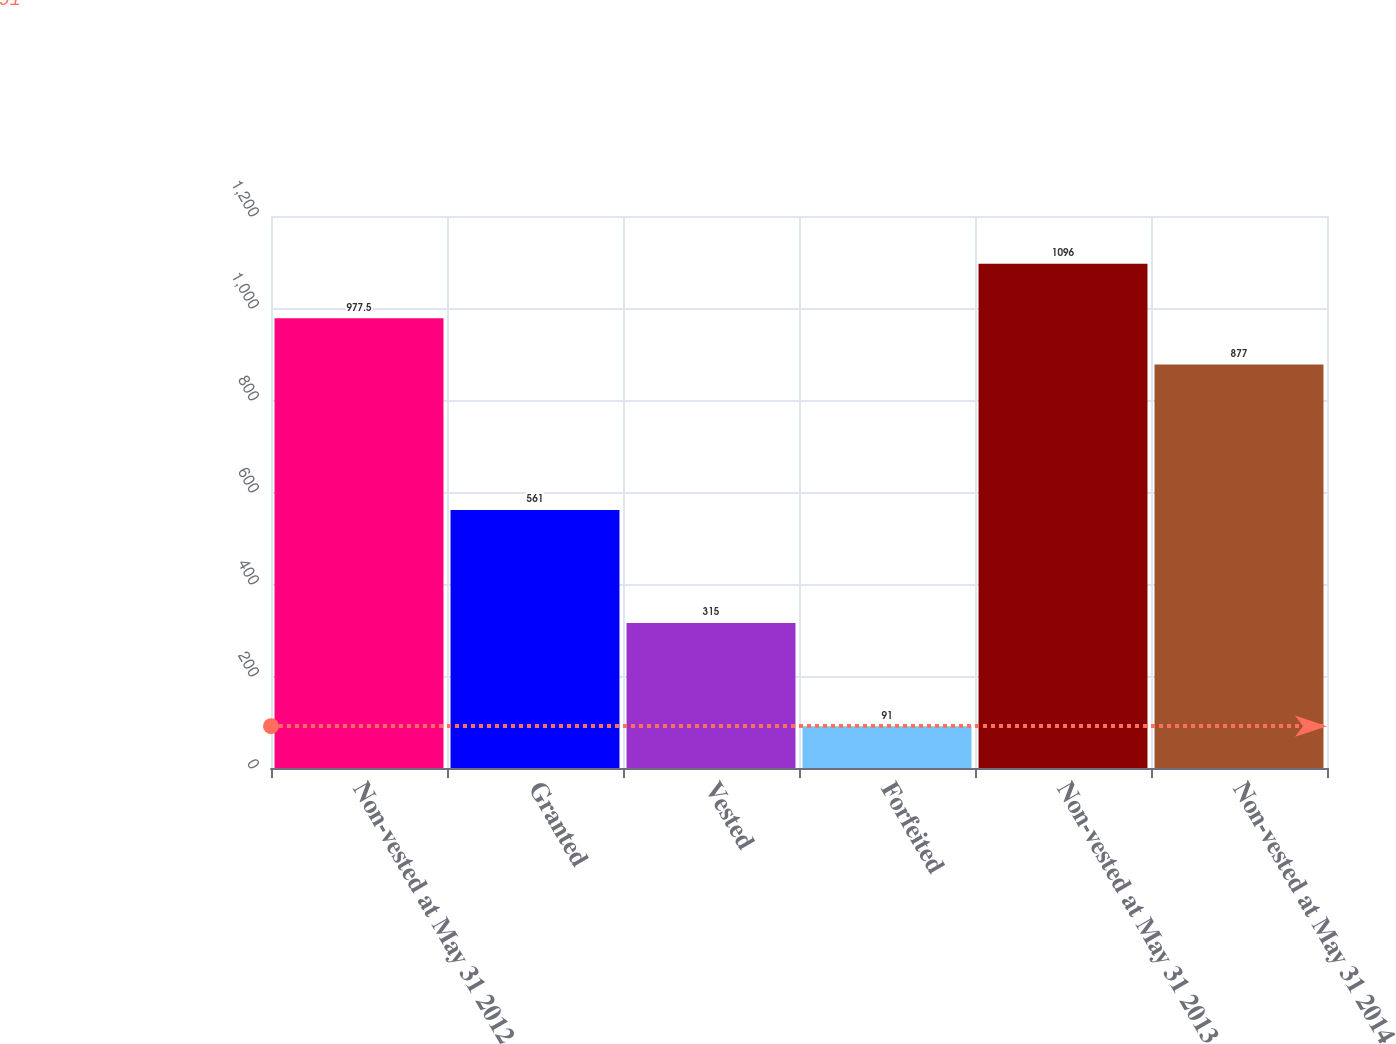<chart> <loc_0><loc_0><loc_500><loc_500><bar_chart><fcel>Non-vested at May 31 2012<fcel>Granted<fcel>Vested<fcel>Forfeited<fcel>Non-vested at May 31 2013<fcel>Non-vested at May 31 2014<nl><fcel>977.5<fcel>561<fcel>315<fcel>91<fcel>1096<fcel>877<nl></chart> 